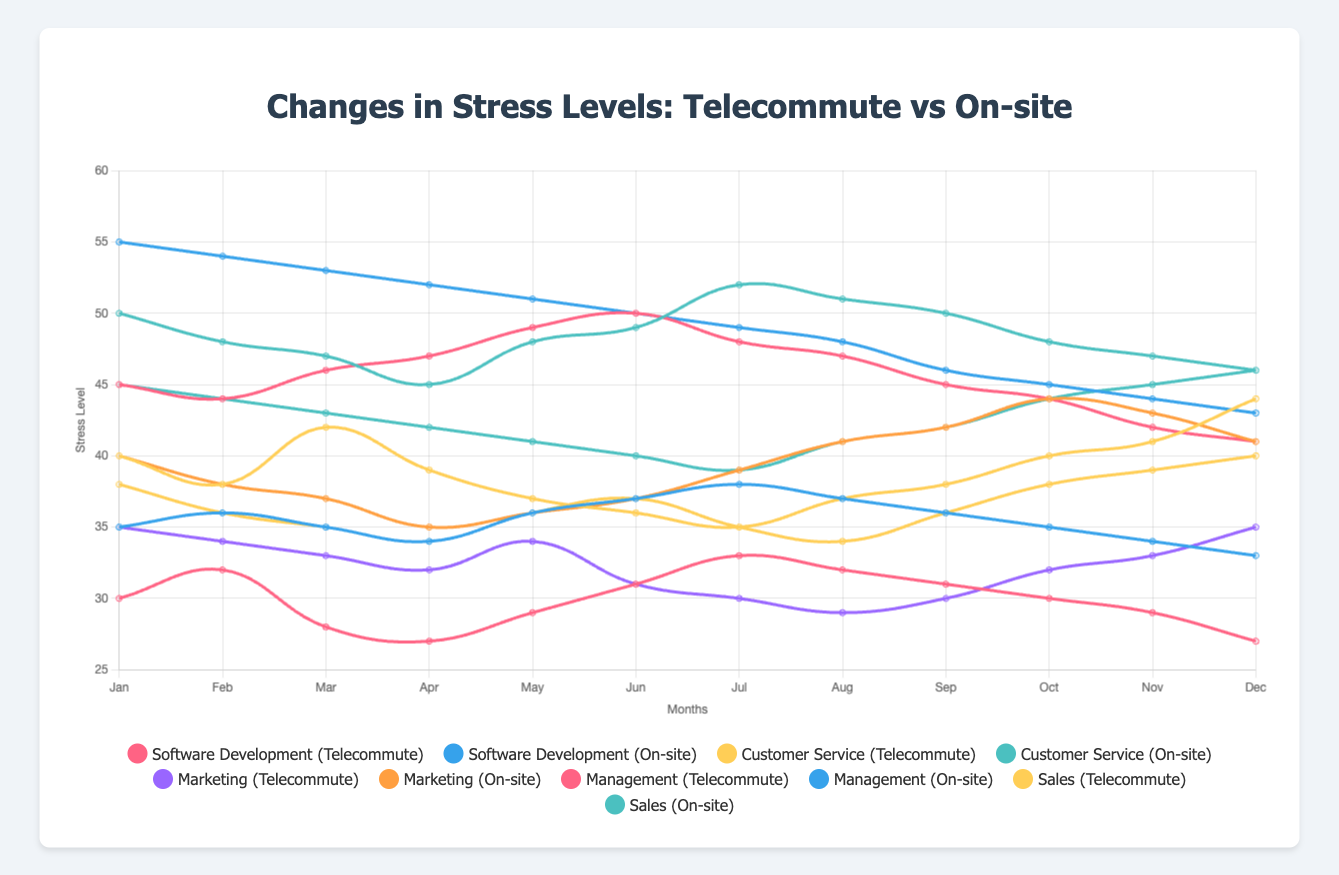How do stress levels in Software Development compare between telecommuting and on-site employees in January? In January, the stress level for telecommuters in Software Development is 30, while it is 35 for on-site employees. Therefore, telecommuters have a lower stress level.
Answer: Telecommuters have lower stress levels Which occupation shows the biggest difference in stress levels between telecommuting and on-site employees in August? In August, Management shows the biggest difference. Telecommuters have a stress level of 47, while on-site employees have a stress level of 48. The difference is just 1, but it’s more noticeable compared to other occupations where the values are closer.
Answer: Management What is the average stress level for Marketing employees who telecommute over the year? The stress levels are [35, 34, 33, 32, 34, 31, 30, 29, 30, 32, 33, 35]. Adding these values gives 418. Dividing by 12 (the number of months) gives an average of 34.83.
Answer: 34.83 Which occupation experiences a noticeable stress level drop for telecommuting employees from January to December? Both Marketing and Management have a noticeable drop. Marketing stress levels drop from 35 to 35, which stays consistent throughout the months, while Management drops from 45 to 41.
Answer: Management During which month is the stress level gap between telecommuters and on-site employees in Customer Service the smallest? The stress levels for Customer Service show the smallest gap in June where telecommuters have a stress level of 36 and on-site employees have a stress level of 49. This results in a difference of 13, which is smaller compared to other months.
Answer: June What is the overall trend in stress levels for Sales employees who telecommute throughout the year? The stress levels for telecommuting Sales employees decrease from January (38) to April (34), then increase slightly in the middle months, reaching 40 in December. The overall trend is relatively stable with minor fluctuations.
Answer: Relatively stable Compare the peak stress levels for telecommuting employees in Software Development and Marketing. Which one is higher? The peak stress level for Software Development telecommuters is 33 in July, while for Marketing it is 35 in both January and December. Hence, Marketing’s peak is higher.
Answer: Marketing In which month does Management experience the highest stress level for telecommuters? Management telecommuters experience the highest stress level in June with a value of 50.
Answer: June By how much does the stress level for on-site Customer Service employees decrease from January to December? The stress levels for on-site Customer Service employees decrease from 50 in January to 46 in December. The difference is 4.
Answer: 4 